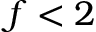Convert formula to latex. <formula><loc_0><loc_0><loc_500><loc_500>f < 2</formula> 